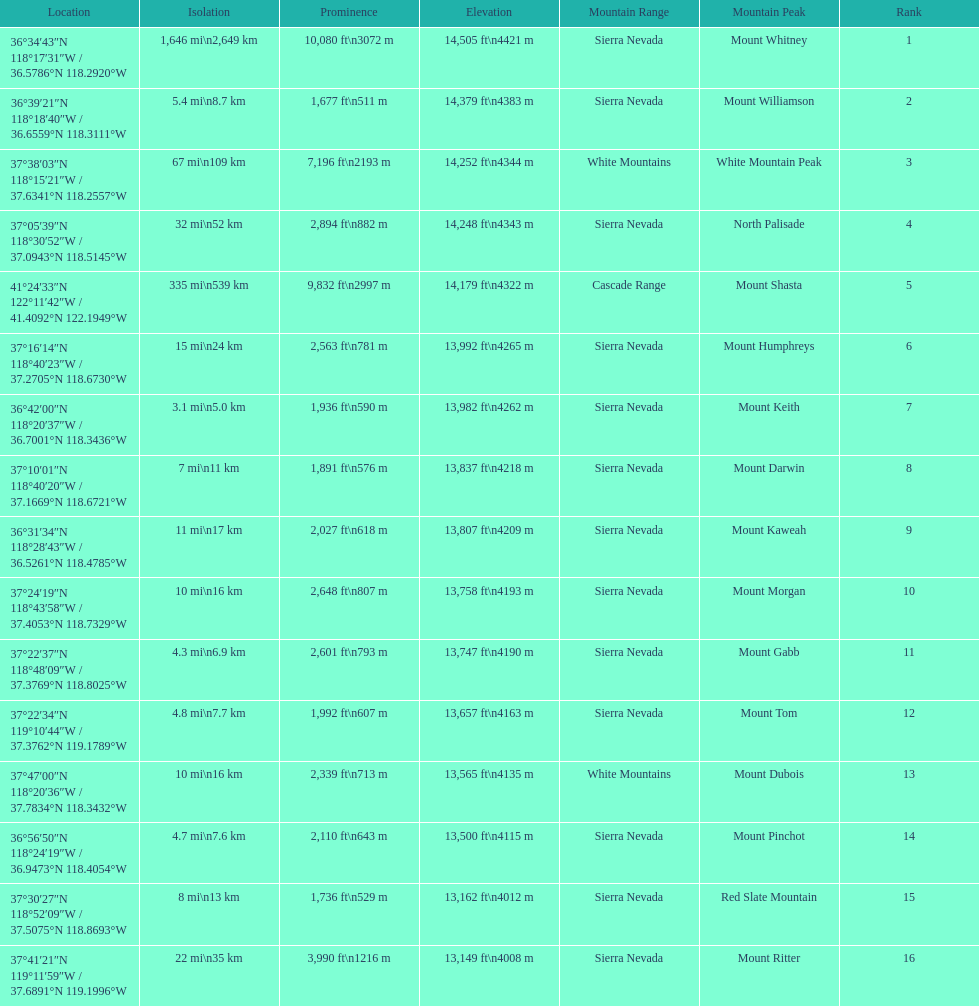Which mountain peak has the least isolation? Mount Keith. 